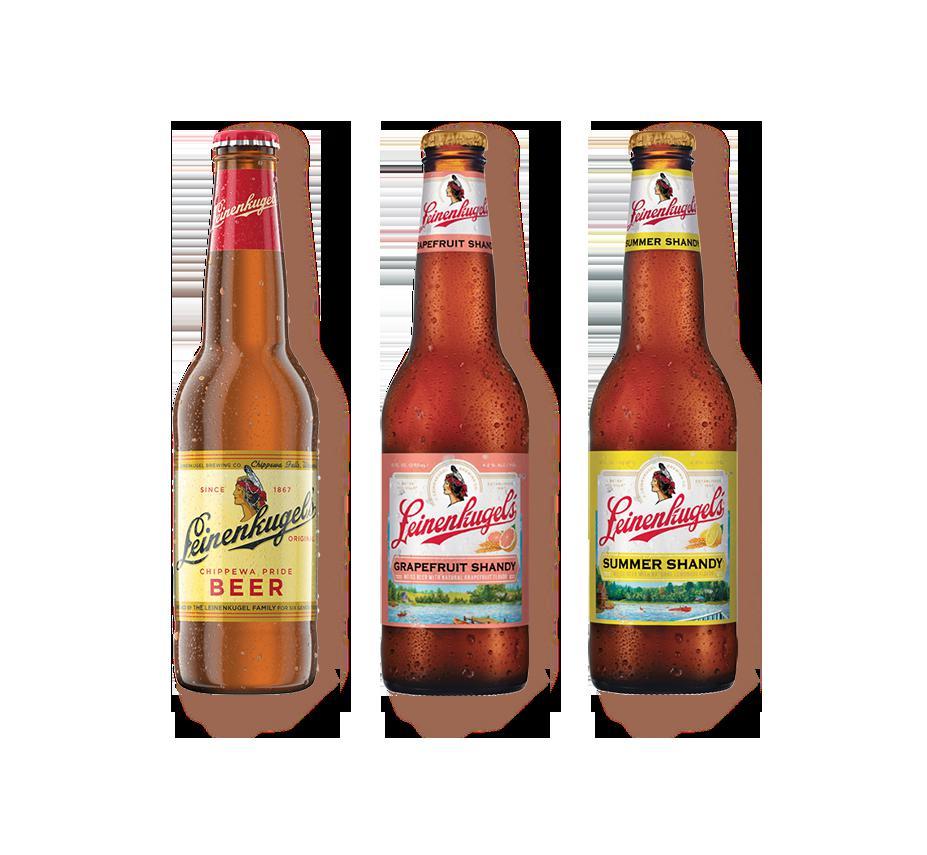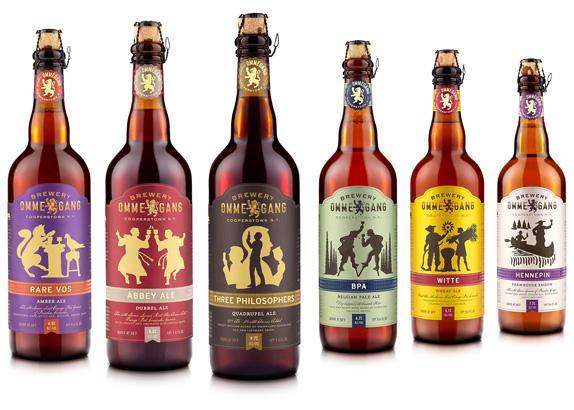The first image is the image on the left, the second image is the image on the right. Given the left and right images, does the statement "There are no more than five beer bottles" hold true? Answer yes or no. No. The first image is the image on the left, the second image is the image on the right. Assess this claim about the two images: "Right and left images show the same number of bottles.". Correct or not? Answer yes or no. No. 